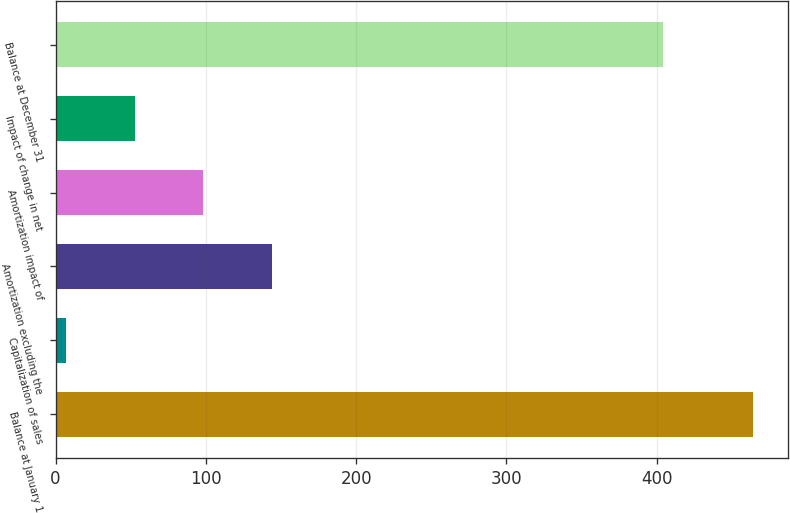<chart> <loc_0><loc_0><loc_500><loc_500><bar_chart><fcel>Balance at January 1<fcel>Capitalization of sales<fcel>Amortization excluding the<fcel>Amortization impact of<fcel>Impact of change in net<fcel>Balance at December 31<nl><fcel>464<fcel>7<fcel>144.1<fcel>98.4<fcel>52.7<fcel>404<nl></chart> 